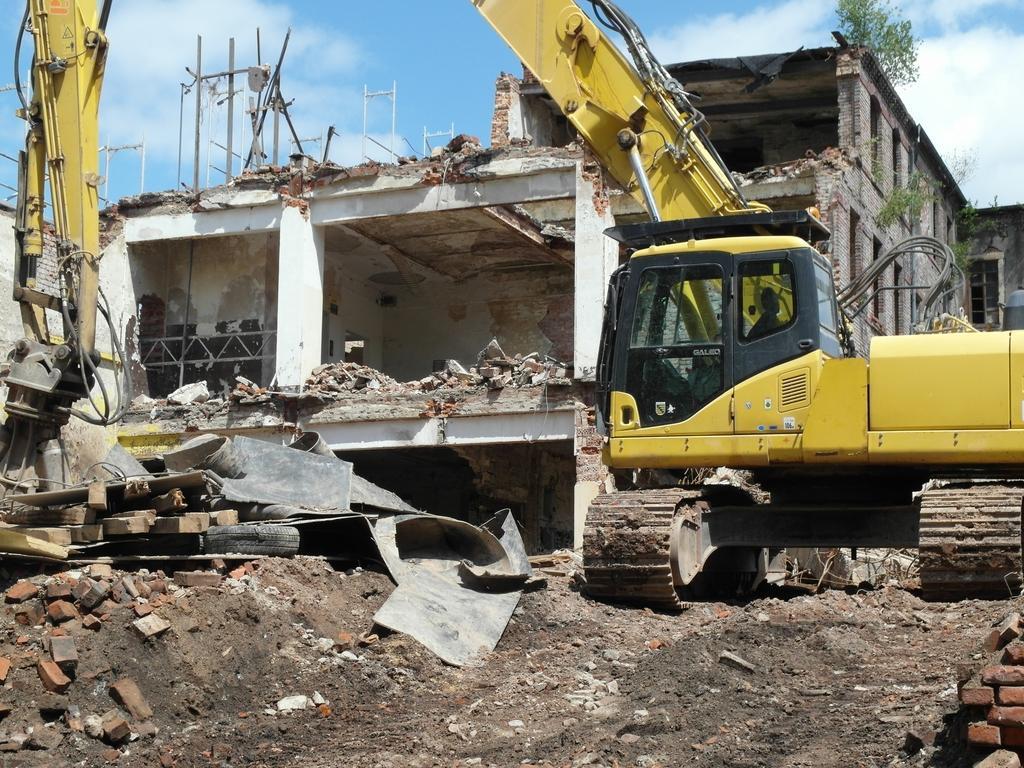How would you summarize this image in a sentence or two? In this image, we can see a building. There is an excavator on the right side of the image. There are wooden poles on the left side of the image. There are bricks in the bottom left and in the bottom right of the image. There is a sky at the top of the image. 